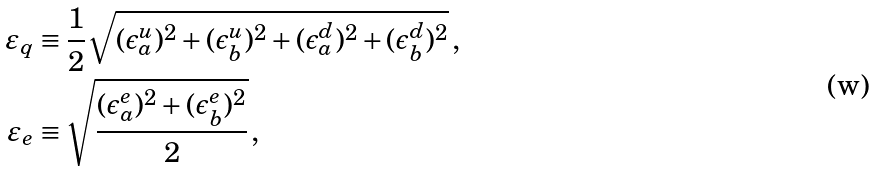Convert formula to latex. <formula><loc_0><loc_0><loc_500><loc_500>\varepsilon _ { q } & \equiv \frac { 1 } { 2 } \sqrt { ( \epsilon ^ { u } _ { a } ) ^ { 2 } + ( \epsilon ^ { u } _ { b } ) ^ { 2 } + ( \epsilon ^ { d } _ { a } ) ^ { 2 } + ( \epsilon ^ { d } _ { b } ) ^ { 2 } } \, , \\ \varepsilon _ { e } & \equiv \sqrt { \frac { ( \epsilon ^ { e } _ { a } ) ^ { 2 } + ( \epsilon ^ { e } _ { b } ) ^ { 2 } } 2 } \, ,</formula> 